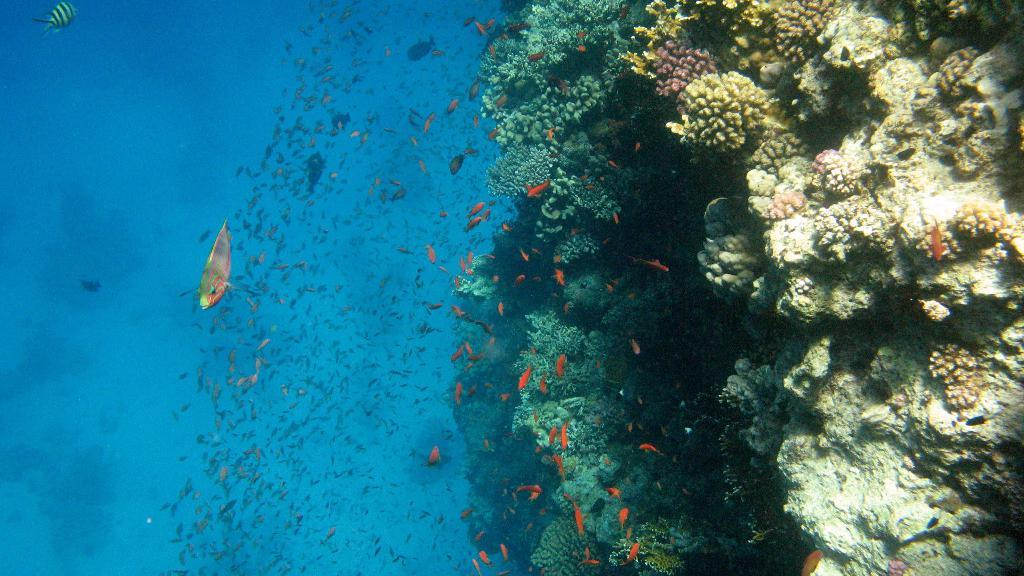What type of animals can be seen in the water in the image? There are fishes in the water in the image. What other marine life can be seen in the image? There are marine organisms on the right side of the image. What type of button can be seen in the garden in the image? There is no button or garden present in the image; it features fishes in the water and marine organisms on the right side. 